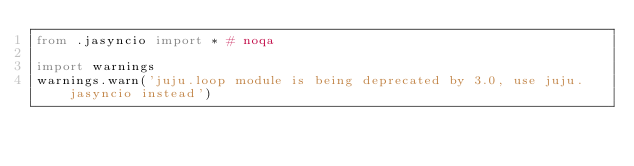Convert code to text. <code><loc_0><loc_0><loc_500><loc_500><_Python_>from .jasyncio import * # noqa

import warnings
warnings.warn('juju.loop module is being deprecated by 3.0, use juju.jasyncio instead')
</code> 